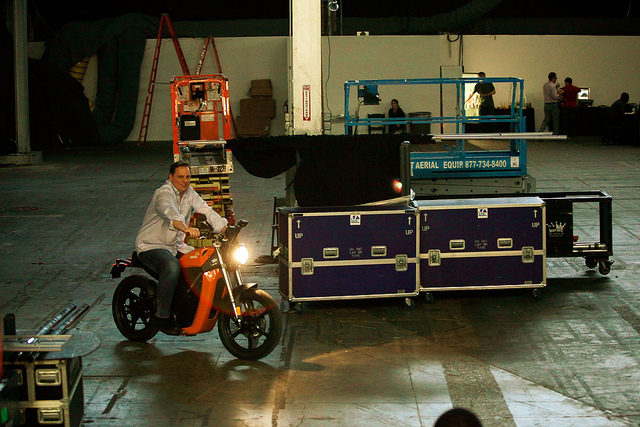Please extract the text content from this image. AERIAL EQUIP. 877 -34C0 UP 